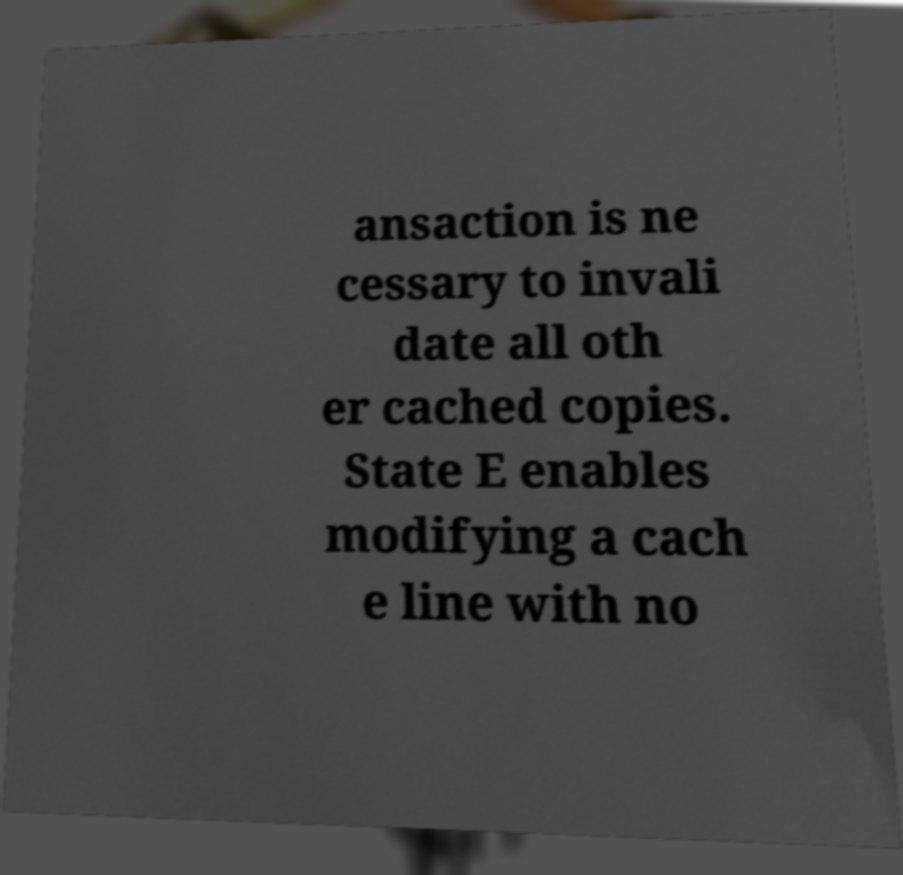Can you read and provide the text displayed in the image?This photo seems to have some interesting text. Can you extract and type it out for me? ansaction is ne cessary to invali date all oth er cached copies. State E enables modifying a cach e line with no 